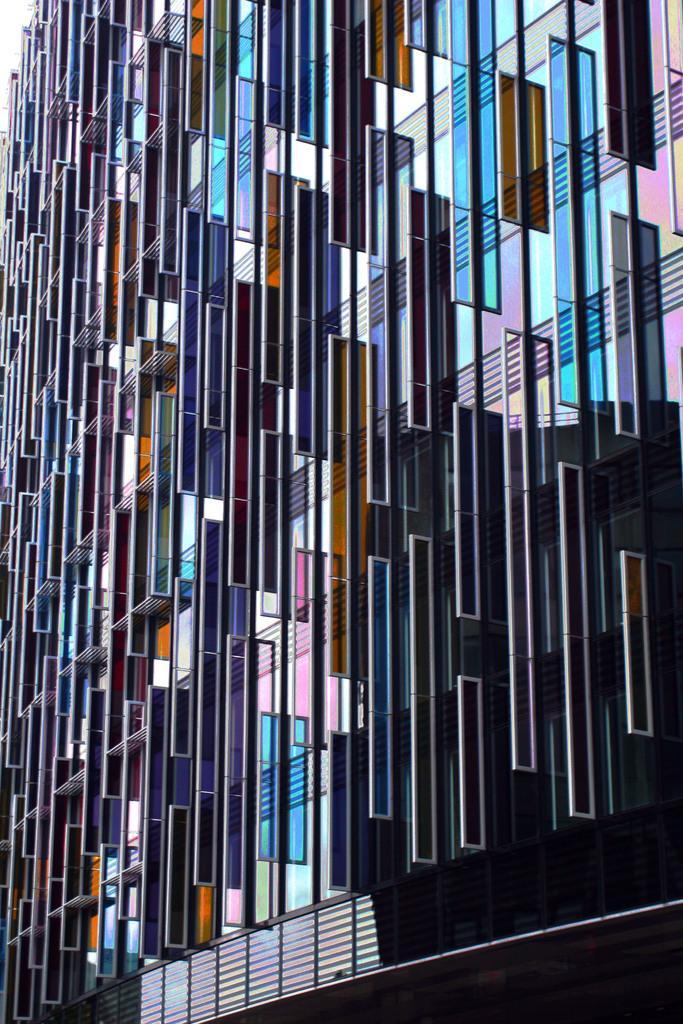Could you give a brief overview of what you see in this image? In this image we can see different glass frames placed on a building. 